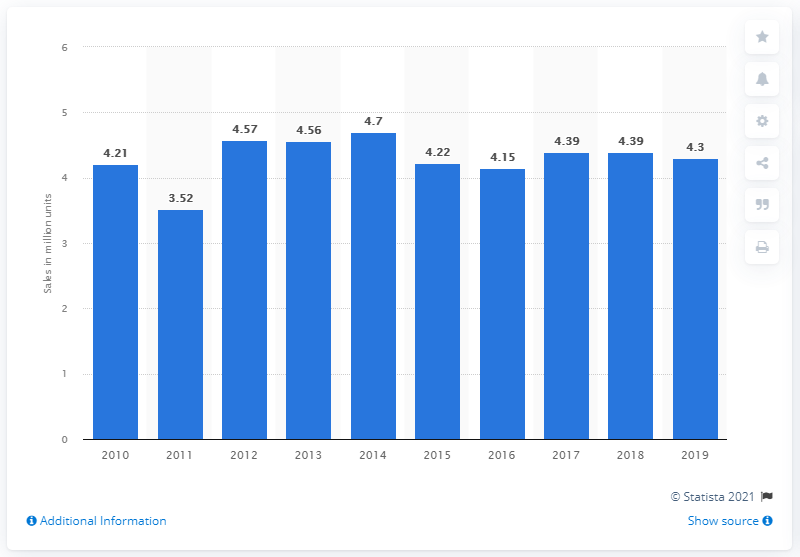Indicate a few pertinent items in this graphic. In 2019, there were 4,300,000 newly registered passenger cars in Japan. 